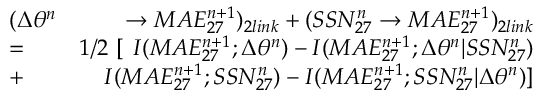Convert formula to latex. <formula><loc_0><loc_0><loc_500><loc_500>\begin{array} { r l r } & { ( \Delta \theta ^ { n } } & { \rightarrow M A E _ { 2 7 } ^ { n + 1 } ) _ { 2 l i n k } + ( S S N _ { 2 7 } ^ { n } \rightarrow M A E _ { 2 7 } ^ { n + 1 } ) _ { 2 l i n k } } \\ & { = } & { 1 / 2 \ [ \ I ( M A E _ { 2 7 } ^ { n + 1 } ; \Delta \theta ^ { n } ) - I ( M A E _ { 2 7 } ^ { n + 1 } ; \Delta \theta ^ { n } | S S N _ { 2 7 } ^ { n } ) } \\ & { + } & { I ( M A E _ { 2 7 } ^ { n + 1 } ; S S N _ { 2 7 } ^ { n } ) - I ( M A E _ { 2 7 } ^ { n + 1 } ; S S N _ { 2 7 } ^ { n } | \Delta \theta ^ { n } ) ] } \end{array}</formula> 